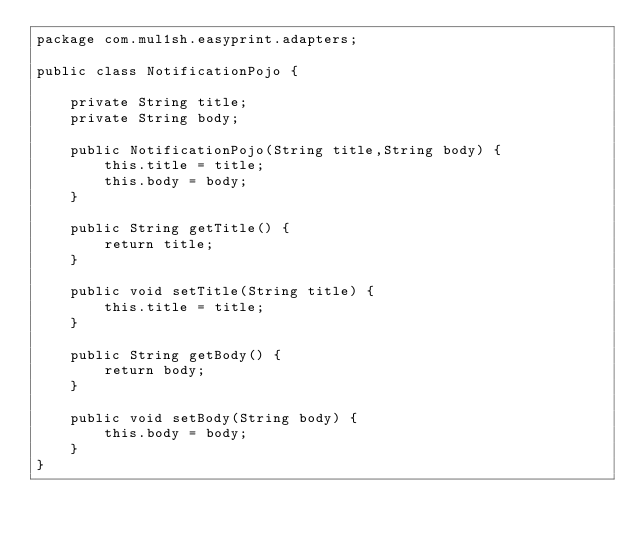<code> <loc_0><loc_0><loc_500><loc_500><_Java_>package com.mul1sh.easyprint.adapters;

public class NotificationPojo {

    private String title;
    private String body;

    public NotificationPojo(String title,String body) {
        this.title = title;
        this.body = body;
    }

    public String getTitle() {
        return title;
    }

    public void setTitle(String title) {
        this.title = title;
    }

    public String getBody() {
        return body;
    }

    public void setBody(String body) {
        this.body = body;
    }
}
</code> 